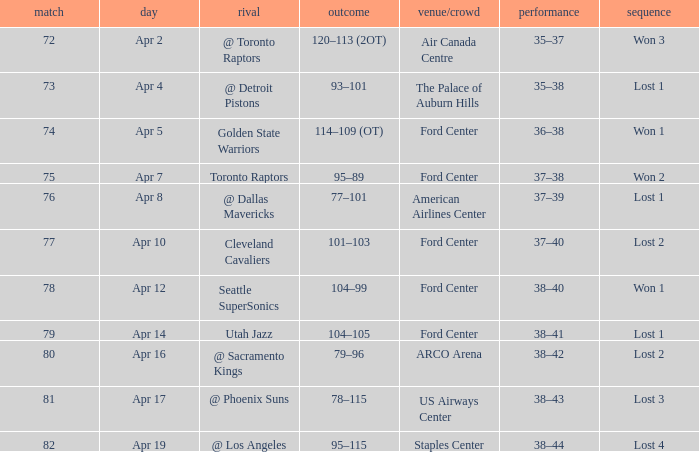What was the record for less than 78 games and a score of 114–109 (ot)? 36–38. Can you give me this table as a dict? {'header': ['match', 'day', 'rival', 'outcome', 'venue/crowd', 'performance', 'sequence'], 'rows': [['72', 'Apr 2', '@ Toronto Raptors', '120–113 (2OT)', 'Air Canada Centre', '35–37', 'Won 3'], ['73', 'Apr 4', '@ Detroit Pistons', '93–101', 'The Palace of Auburn Hills', '35–38', 'Lost 1'], ['74', 'Apr 5', 'Golden State Warriors', '114–109 (OT)', 'Ford Center', '36–38', 'Won 1'], ['75', 'Apr 7', 'Toronto Raptors', '95–89', 'Ford Center', '37–38', 'Won 2'], ['76', 'Apr 8', '@ Dallas Mavericks', '77–101', 'American Airlines Center', '37–39', 'Lost 1'], ['77', 'Apr 10', 'Cleveland Cavaliers', '101–103', 'Ford Center', '37–40', 'Lost 2'], ['78', 'Apr 12', 'Seattle SuperSonics', '104–99', 'Ford Center', '38–40', 'Won 1'], ['79', 'Apr 14', 'Utah Jazz', '104–105', 'Ford Center', '38–41', 'Lost 1'], ['80', 'Apr 16', '@ Sacramento Kings', '79–96', 'ARCO Arena', '38–42', 'Lost 2'], ['81', 'Apr 17', '@ Phoenix Suns', '78–115', 'US Airways Center', '38–43', 'Lost 3'], ['82', 'Apr 19', '@ Los Angeles', '95–115', 'Staples Center', '38–44', 'Lost 4']]} 